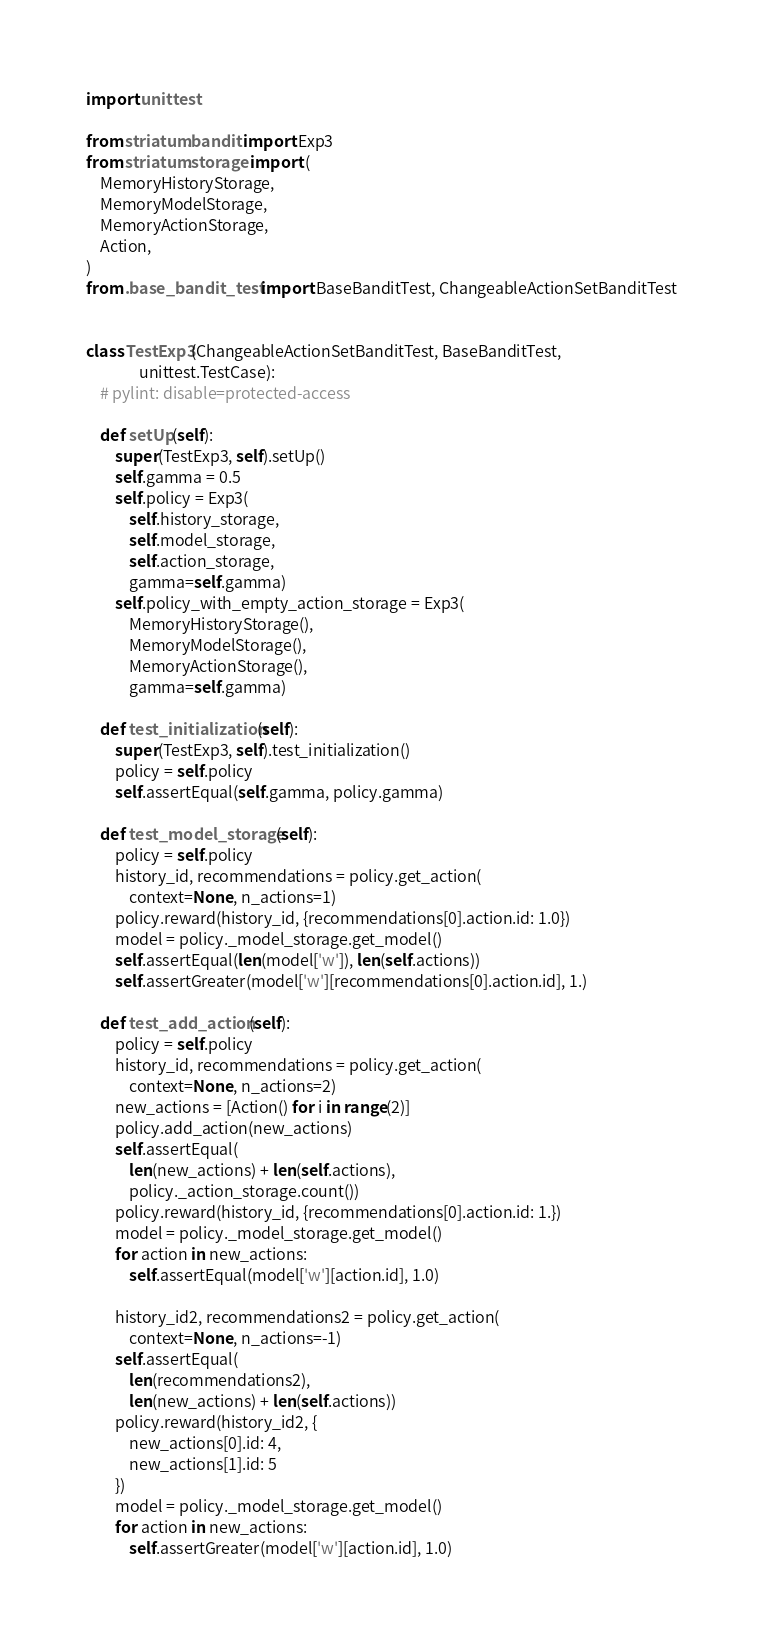Convert code to text. <code><loc_0><loc_0><loc_500><loc_500><_Python_>import unittest

from striatum.bandit import Exp3
from striatum.storage import (
    MemoryHistoryStorage,
    MemoryModelStorage,
    MemoryActionStorage,
    Action,
)
from .base_bandit_test import BaseBanditTest, ChangeableActionSetBanditTest


class TestExp3(ChangeableActionSetBanditTest, BaseBanditTest,
               unittest.TestCase):
    # pylint: disable=protected-access

    def setUp(self):
        super(TestExp3, self).setUp()
        self.gamma = 0.5
        self.policy = Exp3(
            self.history_storage,
            self.model_storage,
            self.action_storage,
            gamma=self.gamma)
        self.policy_with_empty_action_storage = Exp3(
            MemoryHistoryStorage(),
            MemoryModelStorage(),
            MemoryActionStorage(),
            gamma=self.gamma)

    def test_initialization(self):
        super(TestExp3, self).test_initialization()
        policy = self.policy
        self.assertEqual(self.gamma, policy.gamma)

    def test_model_storage(self):
        policy = self.policy
        history_id, recommendations = policy.get_action(
            context=None, n_actions=1)
        policy.reward(history_id, {recommendations[0].action.id: 1.0})
        model = policy._model_storage.get_model()
        self.assertEqual(len(model['w']), len(self.actions))
        self.assertGreater(model['w'][recommendations[0].action.id], 1.)

    def test_add_action(self):
        policy = self.policy
        history_id, recommendations = policy.get_action(
            context=None, n_actions=2)
        new_actions = [Action() for i in range(2)]
        policy.add_action(new_actions)
        self.assertEqual(
            len(new_actions) + len(self.actions),
            policy._action_storage.count())
        policy.reward(history_id, {recommendations[0].action.id: 1.})
        model = policy._model_storage.get_model()
        for action in new_actions:
            self.assertEqual(model['w'][action.id], 1.0)

        history_id2, recommendations2 = policy.get_action(
            context=None, n_actions=-1)
        self.assertEqual(
            len(recommendations2),
            len(new_actions) + len(self.actions))
        policy.reward(history_id2, {
            new_actions[0].id: 4,
            new_actions[1].id: 5
        })
        model = policy._model_storage.get_model()
        for action in new_actions:
            self.assertGreater(model['w'][action.id], 1.0)
</code> 